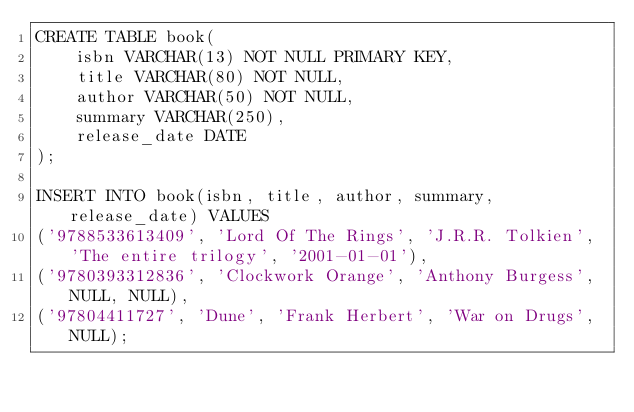Convert code to text. <code><loc_0><loc_0><loc_500><loc_500><_SQL_>CREATE TABLE book(
    isbn VARCHAR(13) NOT NULL PRIMARY KEY,
    title VARCHAR(80) NOT NULL,
    author VARCHAR(50) NOT NULL,
    summary VARCHAR(250),
    release_date DATE
);

INSERT INTO book(isbn, title, author, summary, release_date) VALUES
('9788533613409', 'Lord Of The Rings', 'J.R.R. Tolkien', 'The entire trilogy', '2001-01-01'),
('9780393312836', 'Clockwork Orange', 'Anthony Burgess', NULL, NULL),
('97804411727', 'Dune', 'Frank Herbert', 'War on Drugs', NULL);</code> 